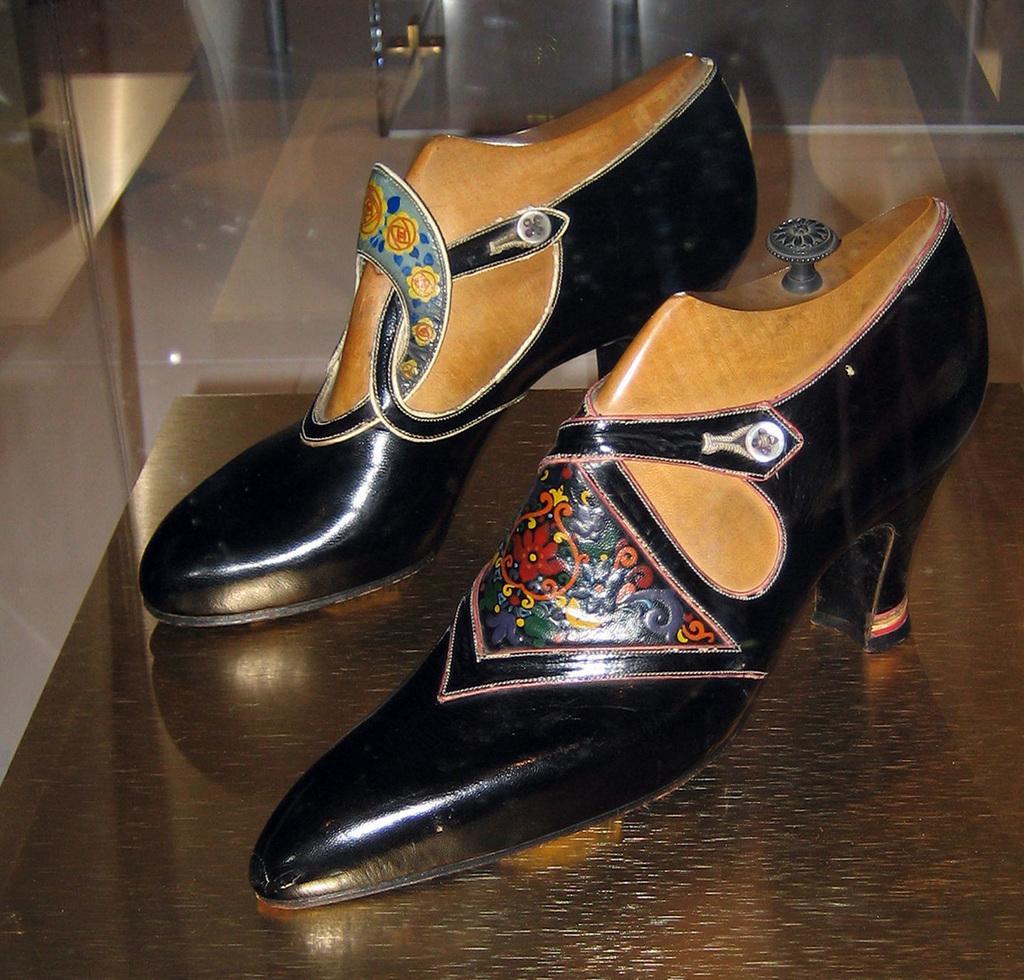Can you describe this image briefly? In this image there is a table truncated towards the bottom of the image, there is a footwear on the table, there is a glass truncated towards the left of the image, there is a glass truncated towards the top of the image, there is a glass truncated towards the right of the image. 